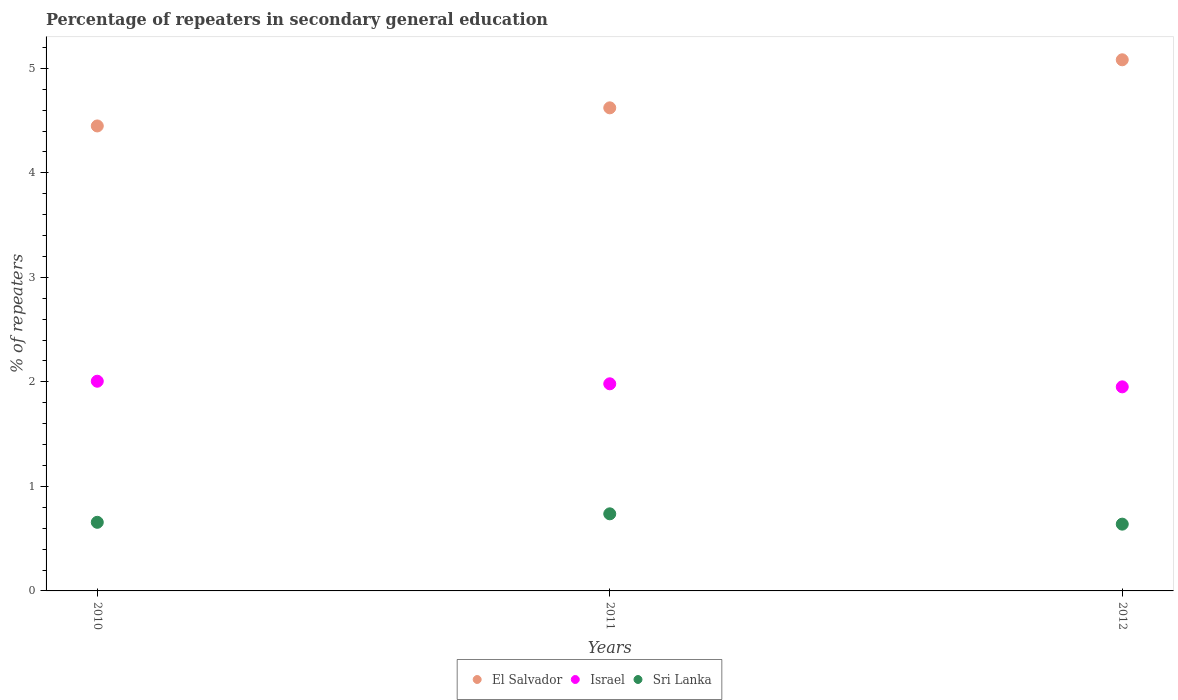How many different coloured dotlines are there?
Offer a terse response. 3. Is the number of dotlines equal to the number of legend labels?
Your answer should be very brief. Yes. What is the percentage of repeaters in secondary general education in El Salvador in 2010?
Your answer should be very brief. 4.45. Across all years, what is the maximum percentage of repeaters in secondary general education in Israel?
Provide a succinct answer. 2.01. Across all years, what is the minimum percentage of repeaters in secondary general education in El Salvador?
Your answer should be compact. 4.45. In which year was the percentage of repeaters in secondary general education in El Salvador maximum?
Your answer should be very brief. 2012. What is the total percentage of repeaters in secondary general education in Israel in the graph?
Your answer should be very brief. 5.94. What is the difference between the percentage of repeaters in secondary general education in Sri Lanka in 2010 and that in 2011?
Ensure brevity in your answer.  -0.08. What is the difference between the percentage of repeaters in secondary general education in Sri Lanka in 2011 and the percentage of repeaters in secondary general education in El Salvador in 2010?
Give a very brief answer. -3.71. What is the average percentage of repeaters in secondary general education in El Salvador per year?
Offer a terse response. 4.72. In the year 2012, what is the difference between the percentage of repeaters in secondary general education in Israel and percentage of repeaters in secondary general education in Sri Lanka?
Offer a terse response. 1.31. In how many years, is the percentage of repeaters in secondary general education in Sri Lanka greater than 3.4 %?
Ensure brevity in your answer.  0. What is the ratio of the percentage of repeaters in secondary general education in Sri Lanka in 2011 to that in 2012?
Provide a short and direct response. 1.15. Is the percentage of repeaters in secondary general education in Sri Lanka in 2011 less than that in 2012?
Keep it short and to the point. No. What is the difference between the highest and the second highest percentage of repeaters in secondary general education in Sri Lanka?
Offer a terse response. 0.08. What is the difference between the highest and the lowest percentage of repeaters in secondary general education in El Salvador?
Your response must be concise. 0.63. In how many years, is the percentage of repeaters in secondary general education in El Salvador greater than the average percentage of repeaters in secondary general education in El Salvador taken over all years?
Ensure brevity in your answer.  1. Is it the case that in every year, the sum of the percentage of repeaters in secondary general education in El Salvador and percentage of repeaters in secondary general education in Israel  is greater than the percentage of repeaters in secondary general education in Sri Lanka?
Keep it short and to the point. Yes. Does the percentage of repeaters in secondary general education in Israel monotonically increase over the years?
Offer a very short reply. No. Is the percentage of repeaters in secondary general education in Sri Lanka strictly greater than the percentage of repeaters in secondary general education in Israel over the years?
Your answer should be compact. No. How many years are there in the graph?
Your answer should be very brief. 3. What is the difference between two consecutive major ticks on the Y-axis?
Provide a succinct answer. 1. Does the graph contain grids?
Ensure brevity in your answer.  No. How are the legend labels stacked?
Your response must be concise. Horizontal. What is the title of the graph?
Ensure brevity in your answer.  Percentage of repeaters in secondary general education. Does "India" appear as one of the legend labels in the graph?
Keep it short and to the point. No. What is the label or title of the Y-axis?
Offer a terse response. % of repeaters. What is the % of repeaters in El Salvador in 2010?
Keep it short and to the point. 4.45. What is the % of repeaters in Israel in 2010?
Provide a succinct answer. 2.01. What is the % of repeaters of Sri Lanka in 2010?
Your answer should be compact. 0.66. What is the % of repeaters of El Salvador in 2011?
Offer a very short reply. 4.62. What is the % of repeaters of Israel in 2011?
Your response must be concise. 1.98. What is the % of repeaters of Sri Lanka in 2011?
Your answer should be compact. 0.74. What is the % of repeaters in El Salvador in 2012?
Your answer should be compact. 5.08. What is the % of repeaters in Israel in 2012?
Provide a succinct answer. 1.95. What is the % of repeaters in Sri Lanka in 2012?
Give a very brief answer. 0.64. Across all years, what is the maximum % of repeaters in El Salvador?
Give a very brief answer. 5.08. Across all years, what is the maximum % of repeaters of Israel?
Your answer should be very brief. 2.01. Across all years, what is the maximum % of repeaters of Sri Lanka?
Ensure brevity in your answer.  0.74. Across all years, what is the minimum % of repeaters in El Salvador?
Offer a very short reply. 4.45. Across all years, what is the minimum % of repeaters of Israel?
Offer a terse response. 1.95. Across all years, what is the minimum % of repeaters of Sri Lanka?
Your answer should be very brief. 0.64. What is the total % of repeaters in El Salvador in the graph?
Ensure brevity in your answer.  14.15. What is the total % of repeaters of Israel in the graph?
Provide a short and direct response. 5.94. What is the total % of repeaters in Sri Lanka in the graph?
Provide a short and direct response. 2.03. What is the difference between the % of repeaters in El Salvador in 2010 and that in 2011?
Keep it short and to the point. -0.17. What is the difference between the % of repeaters in Israel in 2010 and that in 2011?
Provide a short and direct response. 0.02. What is the difference between the % of repeaters in Sri Lanka in 2010 and that in 2011?
Your response must be concise. -0.08. What is the difference between the % of repeaters in El Salvador in 2010 and that in 2012?
Offer a very short reply. -0.63. What is the difference between the % of repeaters in Israel in 2010 and that in 2012?
Provide a short and direct response. 0.05. What is the difference between the % of repeaters in Sri Lanka in 2010 and that in 2012?
Provide a short and direct response. 0.02. What is the difference between the % of repeaters of El Salvador in 2011 and that in 2012?
Your answer should be very brief. -0.46. What is the difference between the % of repeaters in Israel in 2011 and that in 2012?
Provide a short and direct response. 0.03. What is the difference between the % of repeaters in Sri Lanka in 2011 and that in 2012?
Offer a very short reply. 0.1. What is the difference between the % of repeaters of El Salvador in 2010 and the % of repeaters of Israel in 2011?
Provide a short and direct response. 2.47. What is the difference between the % of repeaters of El Salvador in 2010 and the % of repeaters of Sri Lanka in 2011?
Ensure brevity in your answer.  3.71. What is the difference between the % of repeaters in Israel in 2010 and the % of repeaters in Sri Lanka in 2011?
Give a very brief answer. 1.27. What is the difference between the % of repeaters of El Salvador in 2010 and the % of repeaters of Israel in 2012?
Keep it short and to the point. 2.5. What is the difference between the % of repeaters of El Salvador in 2010 and the % of repeaters of Sri Lanka in 2012?
Keep it short and to the point. 3.81. What is the difference between the % of repeaters of Israel in 2010 and the % of repeaters of Sri Lanka in 2012?
Offer a terse response. 1.37. What is the difference between the % of repeaters in El Salvador in 2011 and the % of repeaters in Israel in 2012?
Ensure brevity in your answer.  2.67. What is the difference between the % of repeaters in El Salvador in 2011 and the % of repeaters in Sri Lanka in 2012?
Your response must be concise. 3.98. What is the difference between the % of repeaters of Israel in 2011 and the % of repeaters of Sri Lanka in 2012?
Provide a succinct answer. 1.34. What is the average % of repeaters in El Salvador per year?
Your answer should be very brief. 4.72. What is the average % of repeaters in Israel per year?
Keep it short and to the point. 1.98. What is the average % of repeaters in Sri Lanka per year?
Your response must be concise. 0.68. In the year 2010, what is the difference between the % of repeaters of El Salvador and % of repeaters of Israel?
Your response must be concise. 2.44. In the year 2010, what is the difference between the % of repeaters of El Salvador and % of repeaters of Sri Lanka?
Provide a succinct answer. 3.79. In the year 2010, what is the difference between the % of repeaters in Israel and % of repeaters in Sri Lanka?
Offer a very short reply. 1.35. In the year 2011, what is the difference between the % of repeaters of El Salvador and % of repeaters of Israel?
Ensure brevity in your answer.  2.64. In the year 2011, what is the difference between the % of repeaters of El Salvador and % of repeaters of Sri Lanka?
Make the answer very short. 3.88. In the year 2011, what is the difference between the % of repeaters in Israel and % of repeaters in Sri Lanka?
Provide a succinct answer. 1.24. In the year 2012, what is the difference between the % of repeaters of El Salvador and % of repeaters of Israel?
Your answer should be very brief. 3.13. In the year 2012, what is the difference between the % of repeaters in El Salvador and % of repeaters in Sri Lanka?
Offer a terse response. 4.44. In the year 2012, what is the difference between the % of repeaters of Israel and % of repeaters of Sri Lanka?
Make the answer very short. 1.31. What is the ratio of the % of repeaters of El Salvador in 2010 to that in 2011?
Give a very brief answer. 0.96. What is the ratio of the % of repeaters in Israel in 2010 to that in 2011?
Give a very brief answer. 1.01. What is the ratio of the % of repeaters in Sri Lanka in 2010 to that in 2011?
Your response must be concise. 0.89. What is the ratio of the % of repeaters in El Salvador in 2010 to that in 2012?
Offer a very short reply. 0.88. What is the ratio of the % of repeaters in Israel in 2010 to that in 2012?
Your answer should be very brief. 1.03. What is the ratio of the % of repeaters of Sri Lanka in 2010 to that in 2012?
Make the answer very short. 1.03. What is the ratio of the % of repeaters in El Salvador in 2011 to that in 2012?
Provide a short and direct response. 0.91. What is the ratio of the % of repeaters in Israel in 2011 to that in 2012?
Offer a terse response. 1.01. What is the ratio of the % of repeaters of Sri Lanka in 2011 to that in 2012?
Ensure brevity in your answer.  1.15. What is the difference between the highest and the second highest % of repeaters of El Salvador?
Provide a succinct answer. 0.46. What is the difference between the highest and the second highest % of repeaters in Israel?
Offer a very short reply. 0.02. What is the difference between the highest and the second highest % of repeaters in Sri Lanka?
Give a very brief answer. 0.08. What is the difference between the highest and the lowest % of repeaters of El Salvador?
Make the answer very short. 0.63. What is the difference between the highest and the lowest % of repeaters of Israel?
Provide a succinct answer. 0.05. What is the difference between the highest and the lowest % of repeaters of Sri Lanka?
Provide a short and direct response. 0.1. 